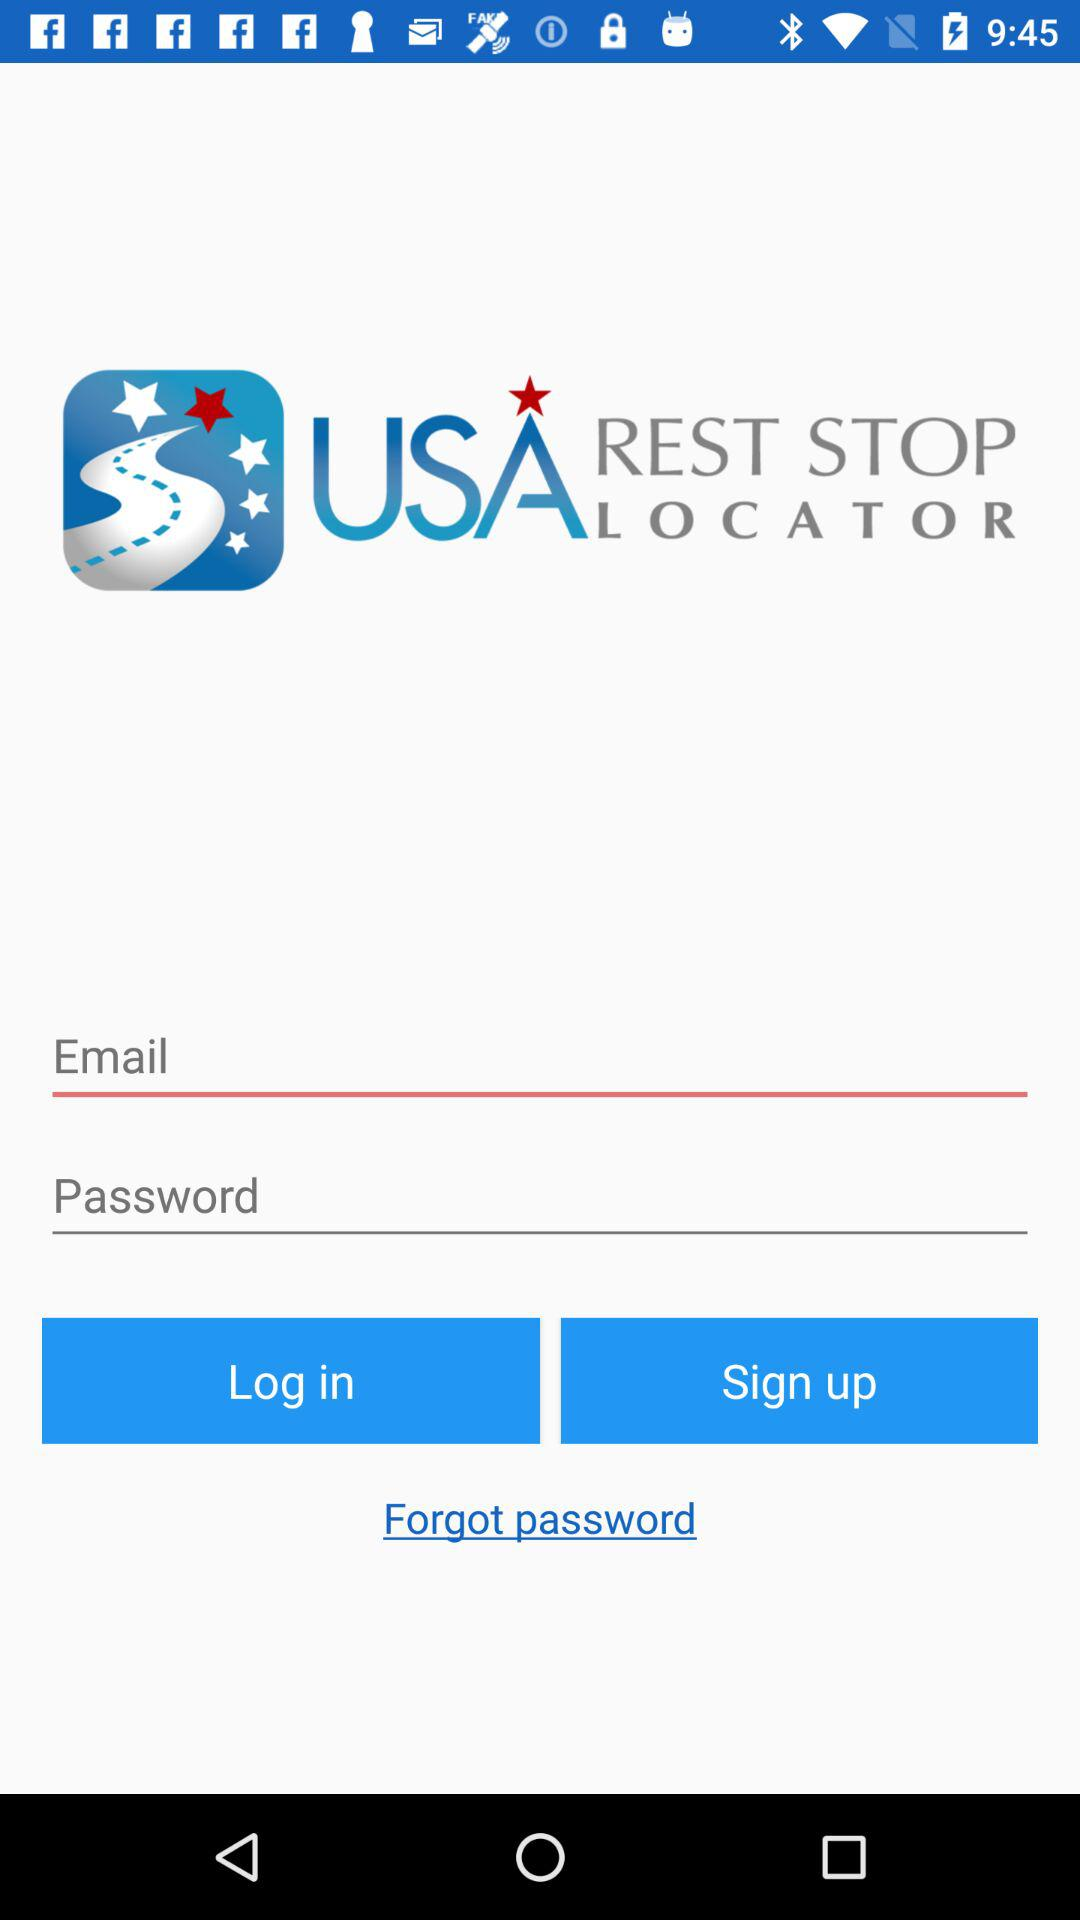What is the application name? The application name is "USA REST STOP LOCATOR". 